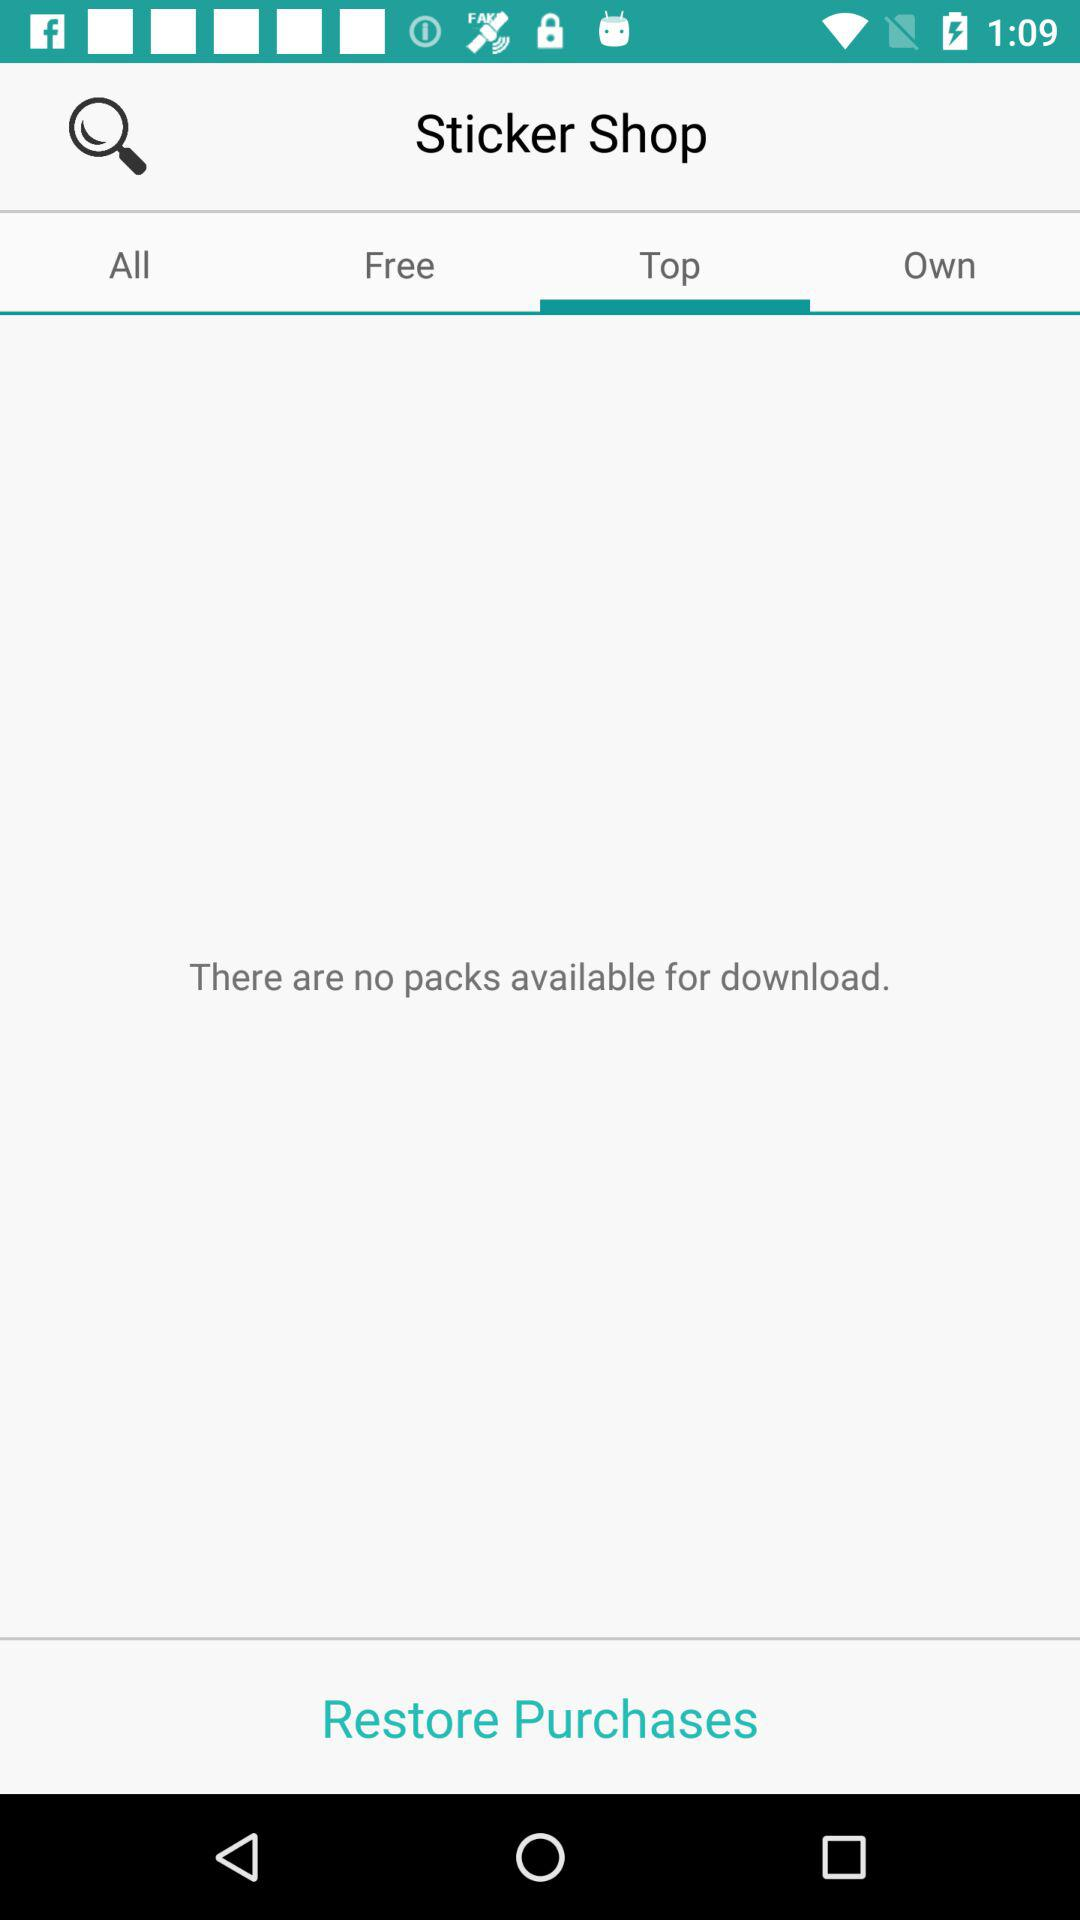How many packs are available? There are no packs available. 